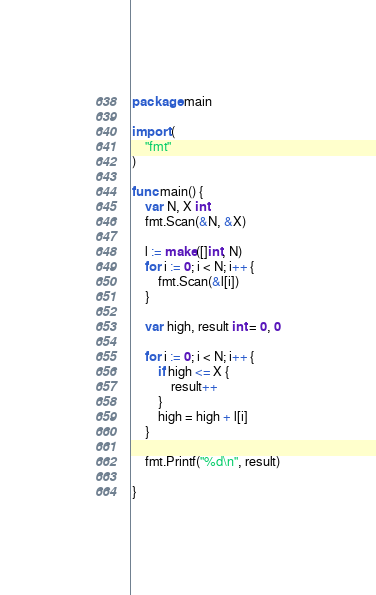Convert code to text. <code><loc_0><loc_0><loc_500><loc_500><_Go_>package main

import (
	"fmt"
)

func main() {
	var N, X int
	fmt.Scan(&N, &X)

	l := make([]int, N)
	for i := 0; i < N; i++ {
		fmt.Scan(&l[i])
	}

	var high, result int = 0, 0

	for i := 0; i < N; i++ {
		if high <= X {
			result++
		}
		high = high + l[i]
	}

	fmt.Printf("%d\n", result)

}
</code> 